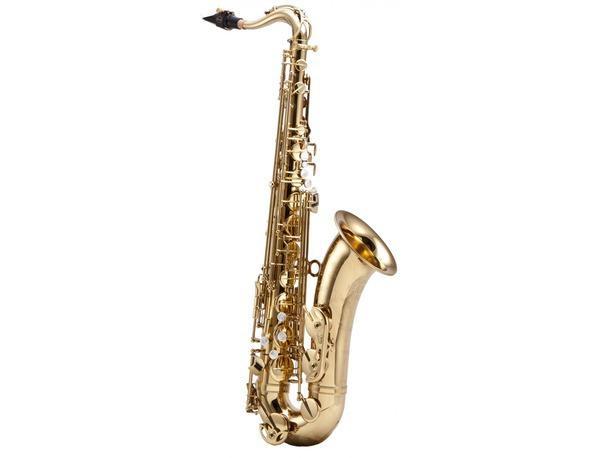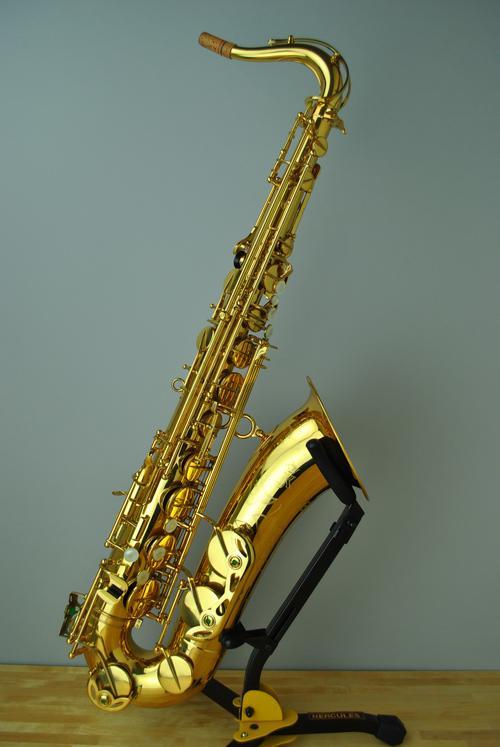The first image is the image on the left, the second image is the image on the right. Considering the images on both sides, is "Each saxophone is displayed nearly vertically with its bell facing rightward, but the saxophone on the right is a brighter, yellower gold color." valid? Answer yes or no. Yes. The first image is the image on the left, the second image is the image on the right. Given the left and right images, does the statement "In at least one image there is a single bras saxophone  with the mouth section tiped left froward with the horn part almost parrellal to the ground." hold true? Answer yes or no. No. 